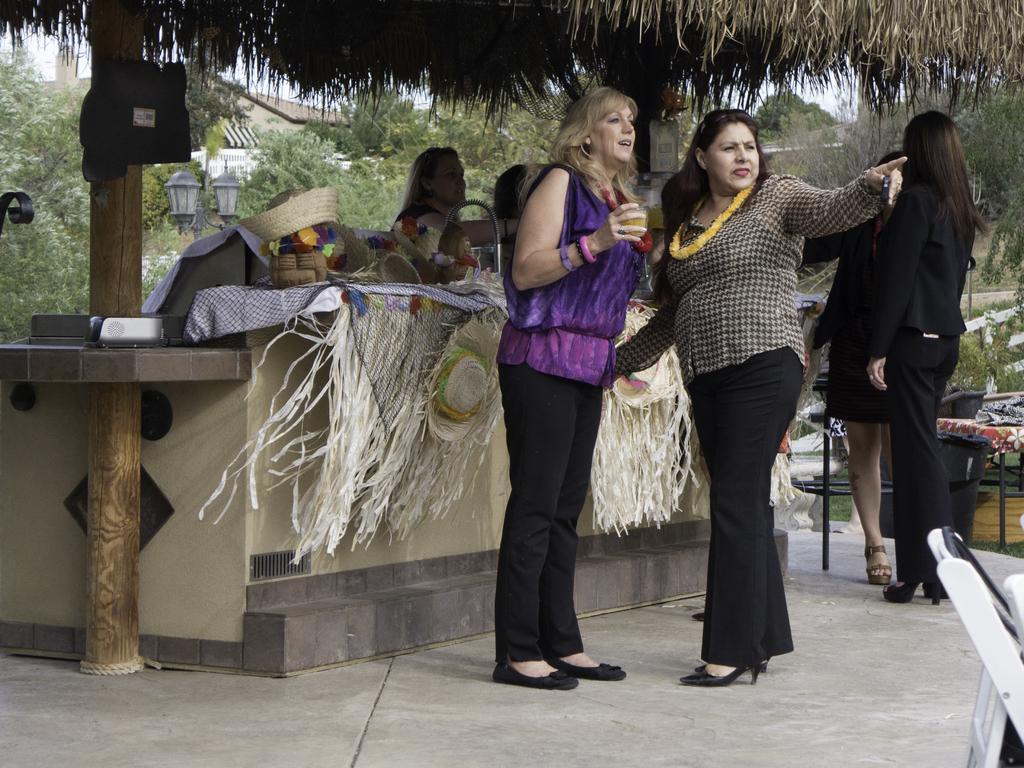Describe this image in one or two sentences. In this image in the foreground there are two women who are standing, and in the background there are some people who are standing and there is one store. In that store there are some hats and some baskets, at the bottom there is a walkway. In the background there are some trees, houses, poles, lights and some other objects. On the left side there is one pillar and some objects. 